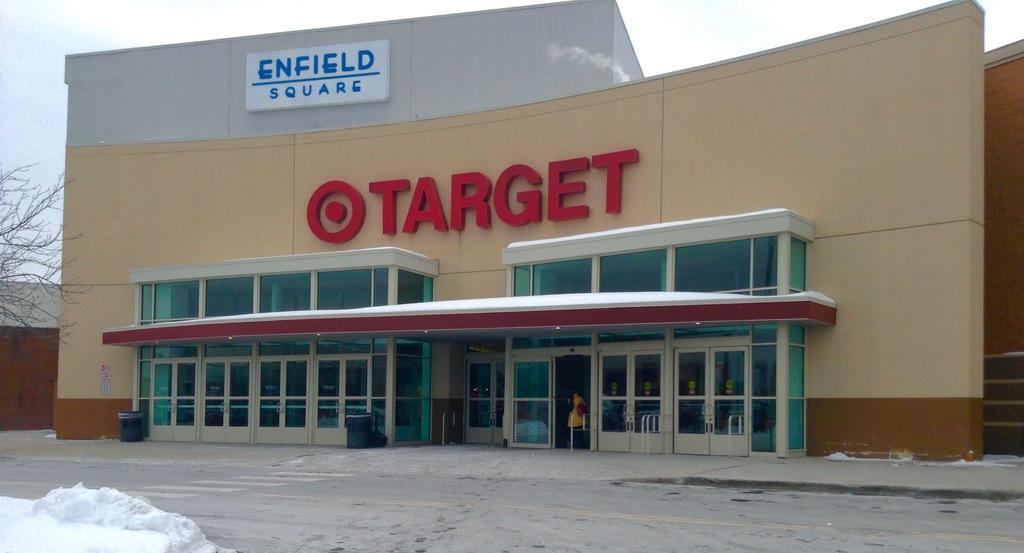In one or two sentences, can you explain what this image depicts? In this image there is a building, on that building there are board on that boards some text is written, in the bottom left there is snow, on the left there is tree. 